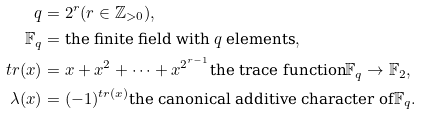<formula> <loc_0><loc_0><loc_500><loc_500>q & = 2 ^ { r } ( r \in \mathbb { Z } _ { > 0 } ) , \\ \mathbb { F } _ { q } & = \text {the finite field with $q$ elements} , \\ t r ( x ) & = x + x ^ { 2 } + \cdots + x ^ { 2 ^ { r - 1 } } \text {the trace function} \mathbb { F } _ { q } \rightarrow \mathbb { F } _ { 2 } , \\ \lambda ( x ) & = ( - 1 ) ^ { t r ( x ) } \text {the canonical additive character of} \mathbb { F } _ { q } .</formula> 